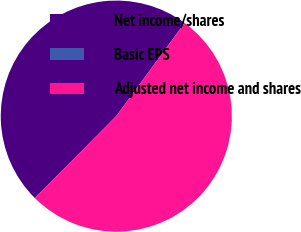Convert chart to OTSL. <chart><loc_0><loc_0><loc_500><loc_500><pie_chart><fcel>Net income/shares<fcel>Basic EPS<fcel>Adjusted net income and shares<nl><fcel>47.62%<fcel>0.0%<fcel>52.38%<nl></chart> 